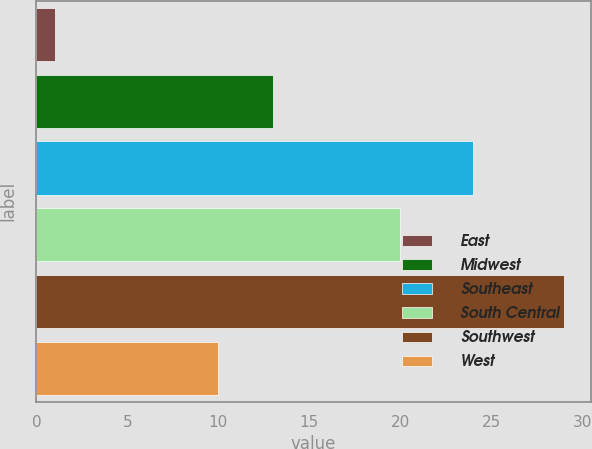Convert chart. <chart><loc_0><loc_0><loc_500><loc_500><bar_chart><fcel>East<fcel>Midwest<fcel>Southeast<fcel>South Central<fcel>Southwest<fcel>West<nl><fcel>1<fcel>13<fcel>24<fcel>20<fcel>29<fcel>10<nl></chart> 